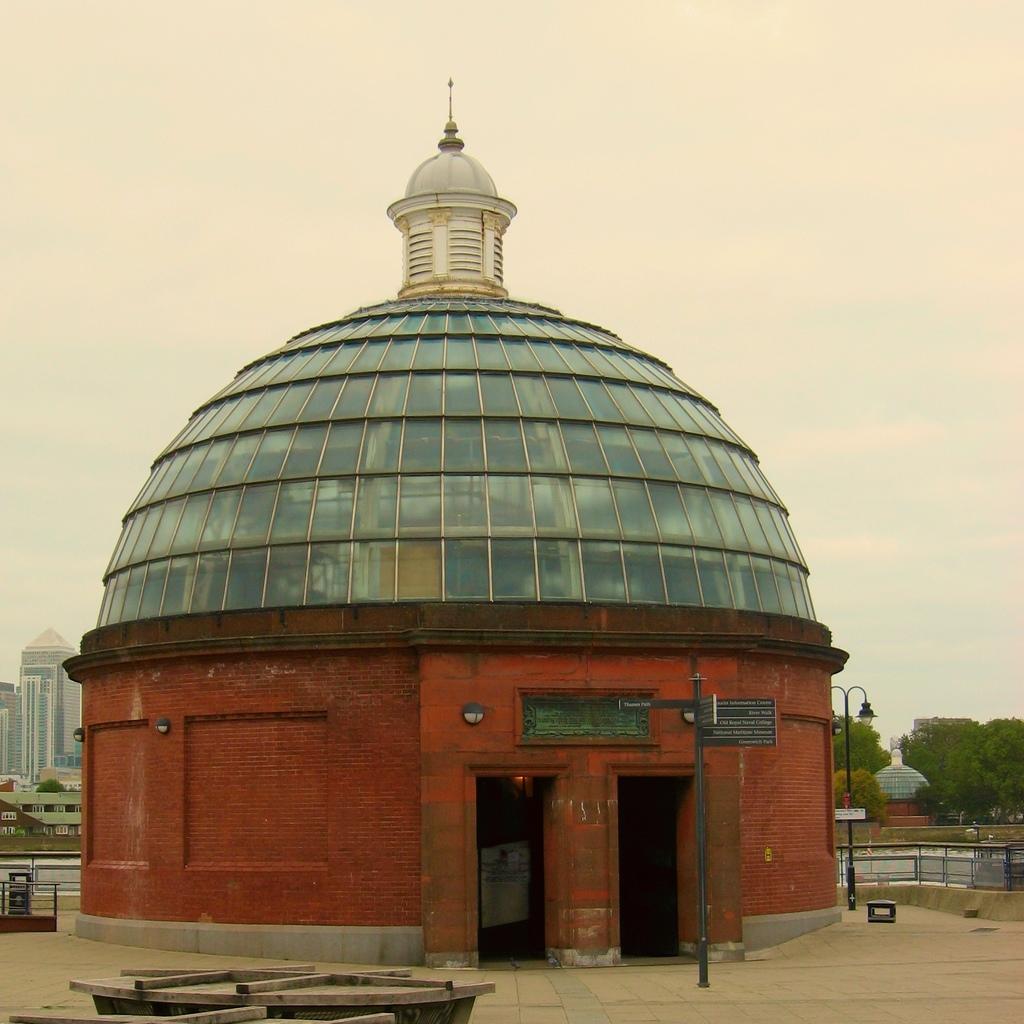Describe this image in one or two sentences. In the center of the image there is a brick structure with glass. In the background of the image there are trees, buildings and sky. At the bottom of the image there is floor. 